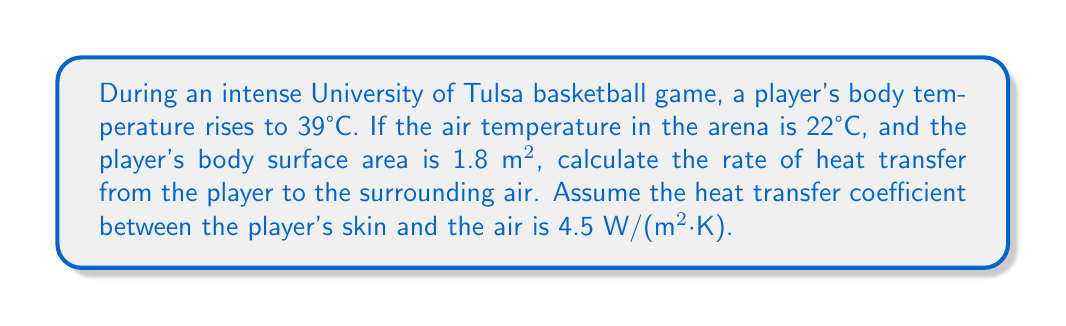Show me your answer to this math problem. To solve this problem, we'll use Newton's Law of Cooling:

$$ Q = hA(T_s - T_∞) $$

Where:
$Q$ = rate of heat transfer (W)
$h$ = heat transfer coefficient (W/(m²·K))
$A$ = surface area (m²)
$T_s$ = surface temperature (°C)
$T_∞$ = ambient temperature (°C)

Given:
$h = 4.5$ W/(m²·K)
$A = 1.8$ m²
$T_s = 39°C$
$T_∞ = 22°C$

Step 1: Substitute the values into the equation:

$$ Q = 4.5 \cdot 1.8 \cdot (39 - 22) $$

Step 2: Calculate the temperature difference:
$$ 39 - 22 = 17°C $$

Step 3: Multiply all the values:
$$ Q = 4.5 \cdot 1.8 \cdot 17 $$
$$ Q = 137.7 \text{ W} $$

Therefore, the rate of heat transfer from the player to the surrounding air is 137.7 W.
Answer: 137.7 W 